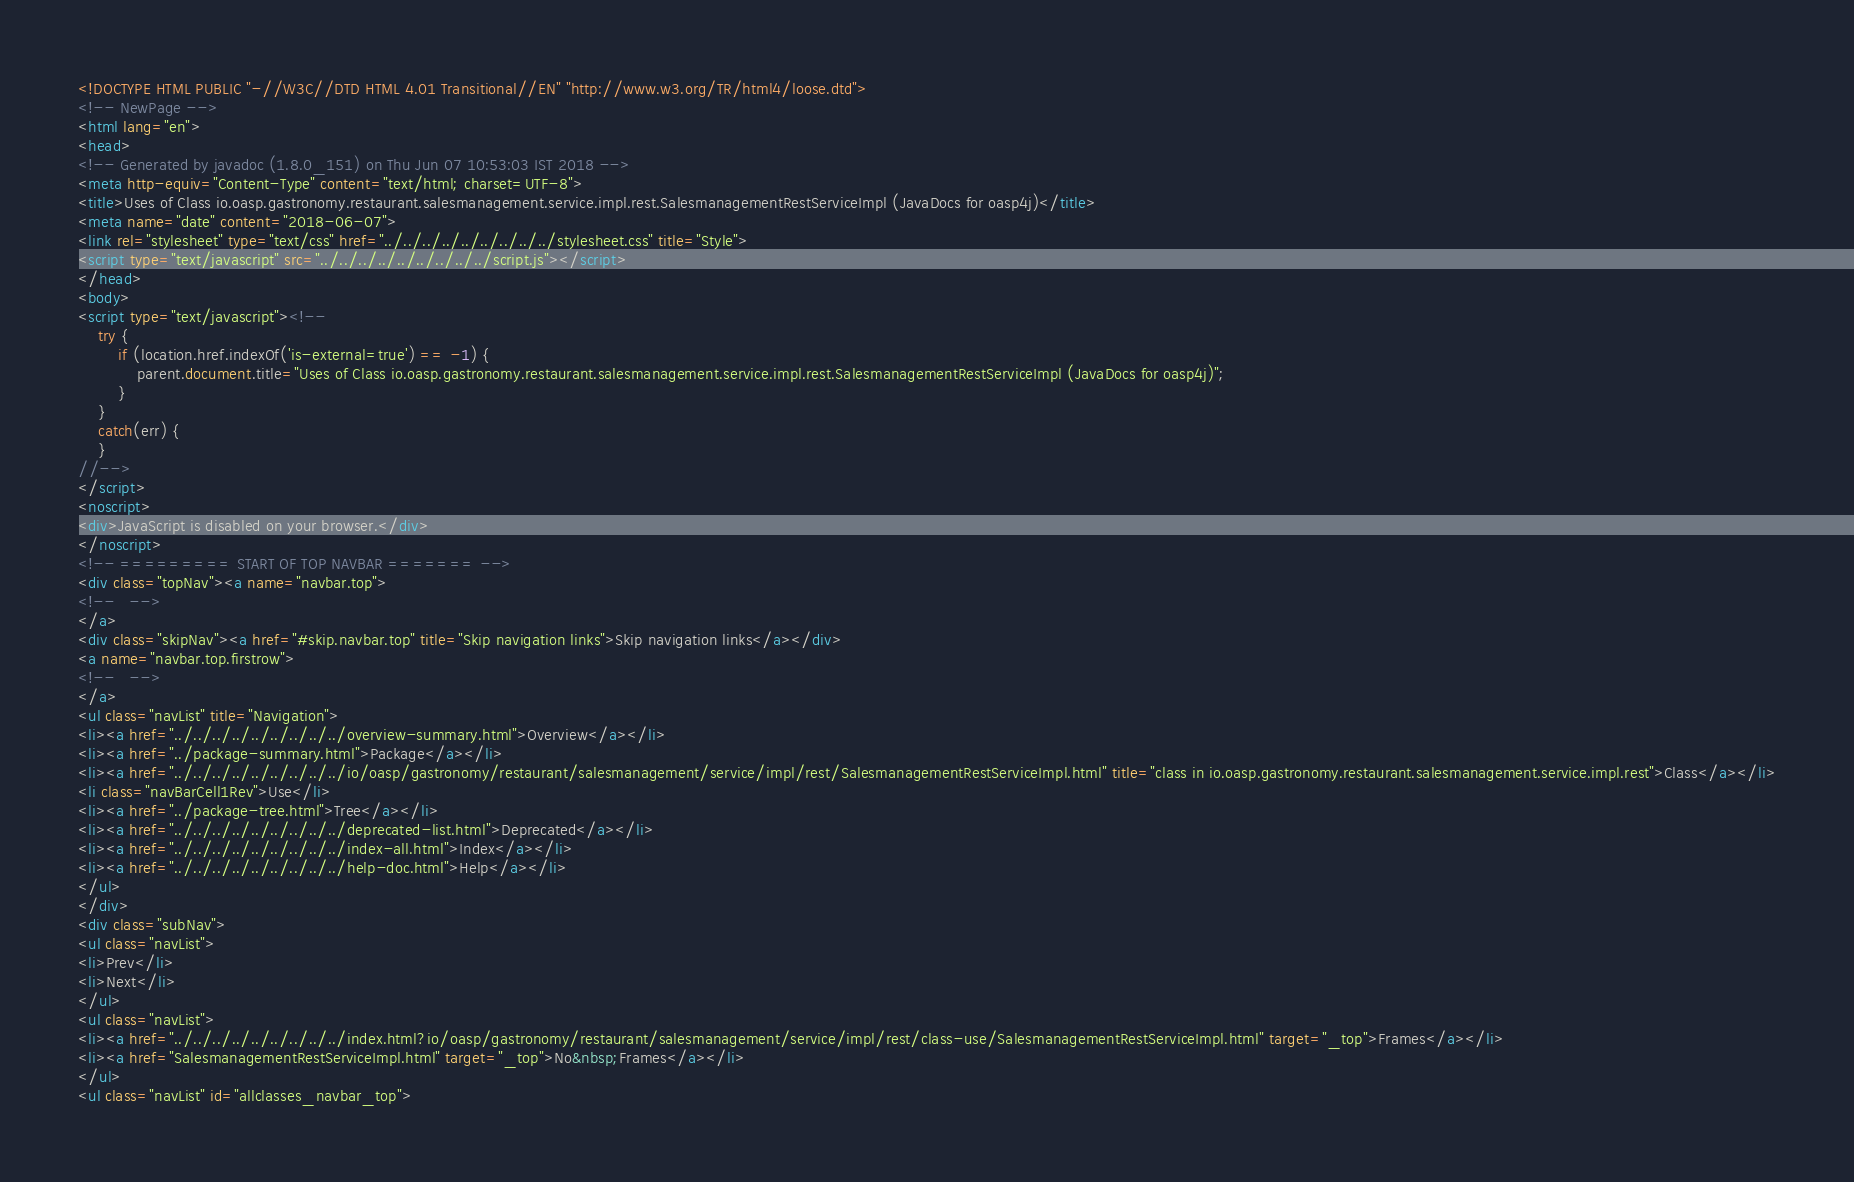Convert code to text. <code><loc_0><loc_0><loc_500><loc_500><_HTML_><!DOCTYPE HTML PUBLIC "-//W3C//DTD HTML 4.01 Transitional//EN" "http://www.w3.org/TR/html4/loose.dtd">
<!-- NewPage -->
<html lang="en">
<head>
<!-- Generated by javadoc (1.8.0_151) on Thu Jun 07 10:53:03 IST 2018 -->
<meta http-equiv="Content-Type" content="text/html; charset=UTF-8">
<title>Uses of Class io.oasp.gastronomy.restaurant.salesmanagement.service.impl.rest.SalesmanagementRestServiceImpl (JavaDocs for oasp4j)</title>
<meta name="date" content="2018-06-07">
<link rel="stylesheet" type="text/css" href="../../../../../../../../../stylesheet.css" title="Style">
<script type="text/javascript" src="../../../../../../../../../script.js"></script>
</head>
<body>
<script type="text/javascript"><!--
    try {
        if (location.href.indexOf('is-external=true') == -1) {
            parent.document.title="Uses of Class io.oasp.gastronomy.restaurant.salesmanagement.service.impl.rest.SalesmanagementRestServiceImpl (JavaDocs for oasp4j)";
        }
    }
    catch(err) {
    }
//-->
</script>
<noscript>
<div>JavaScript is disabled on your browser.</div>
</noscript>
<!-- ========= START OF TOP NAVBAR ======= -->
<div class="topNav"><a name="navbar.top">
<!--   -->
</a>
<div class="skipNav"><a href="#skip.navbar.top" title="Skip navigation links">Skip navigation links</a></div>
<a name="navbar.top.firstrow">
<!--   -->
</a>
<ul class="navList" title="Navigation">
<li><a href="../../../../../../../../../overview-summary.html">Overview</a></li>
<li><a href="../package-summary.html">Package</a></li>
<li><a href="../../../../../../../../../io/oasp/gastronomy/restaurant/salesmanagement/service/impl/rest/SalesmanagementRestServiceImpl.html" title="class in io.oasp.gastronomy.restaurant.salesmanagement.service.impl.rest">Class</a></li>
<li class="navBarCell1Rev">Use</li>
<li><a href="../package-tree.html">Tree</a></li>
<li><a href="../../../../../../../../../deprecated-list.html">Deprecated</a></li>
<li><a href="../../../../../../../../../index-all.html">Index</a></li>
<li><a href="../../../../../../../../../help-doc.html">Help</a></li>
</ul>
</div>
<div class="subNav">
<ul class="navList">
<li>Prev</li>
<li>Next</li>
</ul>
<ul class="navList">
<li><a href="../../../../../../../../../index.html?io/oasp/gastronomy/restaurant/salesmanagement/service/impl/rest/class-use/SalesmanagementRestServiceImpl.html" target="_top">Frames</a></li>
<li><a href="SalesmanagementRestServiceImpl.html" target="_top">No&nbsp;Frames</a></li>
</ul>
<ul class="navList" id="allclasses_navbar_top"></code> 